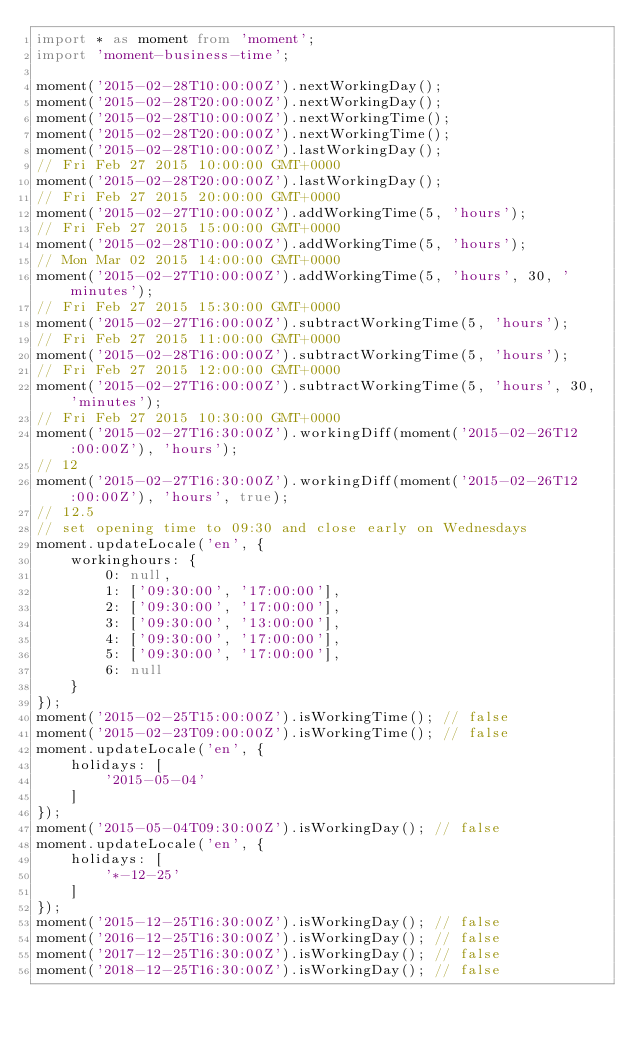<code> <loc_0><loc_0><loc_500><loc_500><_TypeScript_>import * as moment from 'moment';
import 'moment-business-time';

moment('2015-02-28T10:00:00Z').nextWorkingDay();
moment('2015-02-28T20:00:00Z').nextWorkingDay();
moment('2015-02-28T10:00:00Z').nextWorkingTime();
moment('2015-02-28T20:00:00Z').nextWorkingTime();
moment('2015-02-28T10:00:00Z').lastWorkingDay();
// Fri Feb 27 2015 10:00:00 GMT+0000
moment('2015-02-28T20:00:00Z').lastWorkingDay();
// Fri Feb 27 2015 20:00:00 GMT+0000
moment('2015-02-27T10:00:00Z').addWorkingTime(5, 'hours');
// Fri Feb 27 2015 15:00:00 GMT+0000
moment('2015-02-28T10:00:00Z').addWorkingTime(5, 'hours');
// Mon Mar 02 2015 14:00:00 GMT+0000
moment('2015-02-27T10:00:00Z').addWorkingTime(5, 'hours', 30, 'minutes');
// Fri Feb 27 2015 15:30:00 GMT+0000
moment('2015-02-27T16:00:00Z').subtractWorkingTime(5, 'hours');
// Fri Feb 27 2015 11:00:00 GMT+0000
moment('2015-02-28T16:00:00Z').subtractWorkingTime(5, 'hours');
// Fri Feb 27 2015 12:00:00 GMT+0000
moment('2015-02-27T16:00:00Z').subtractWorkingTime(5, 'hours', 30, 'minutes');
// Fri Feb 27 2015 10:30:00 GMT+0000
moment('2015-02-27T16:30:00Z').workingDiff(moment('2015-02-26T12:00:00Z'), 'hours');
// 12
moment('2015-02-27T16:30:00Z').workingDiff(moment('2015-02-26T12:00:00Z'), 'hours', true);
// 12.5
// set opening time to 09:30 and close early on Wednesdays
moment.updateLocale('en', {
    workinghours: {
        0: null,
        1: ['09:30:00', '17:00:00'],
        2: ['09:30:00', '17:00:00'],
        3: ['09:30:00', '13:00:00'],
        4: ['09:30:00', '17:00:00'],
        5: ['09:30:00', '17:00:00'],
        6: null
    }
});
moment('2015-02-25T15:00:00Z').isWorkingTime(); // false
moment('2015-02-23T09:00:00Z').isWorkingTime(); // false
moment.updateLocale('en', {
    holidays: [
        '2015-05-04'
    ]
});
moment('2015-05-04T09:30:00Z').isWorkingDay(); // false
moment.updateLocale('en', {
    holidays: [
        '*-12-25'
    ]
});
moment('2015-12-25T16:30:00Z').isWorkingDay(); // false
moment('2016-12-25T16:30:00Z').isWorkingDay(); // false
moment('2017-12-25T16:30:00Z').isWorkingDay(); // false
moment('2018-12-25T16:30:00Z').isWorkingDay(); // false
</code> 